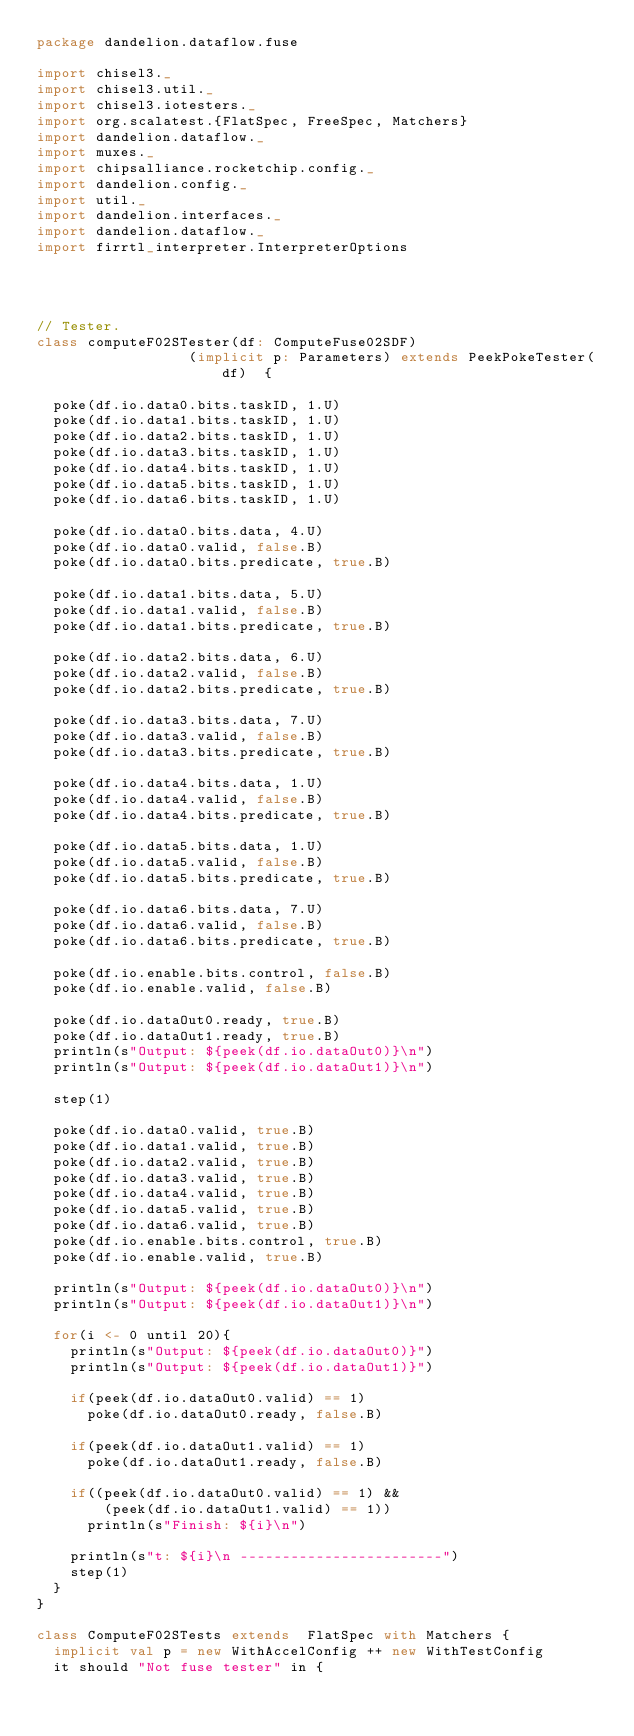Convert code to text. <code><loc_0><loc_0><loc_500><loc_500><_Scala_>package dandelion.dataflow.fuse

import chisel3._
import chisel3.util._
import chisel3.iotesters._
import org.scalatest.{FlatSpec, FreeSpec, Matchers}
import dandelion.dataflow._
import muxes._
import chipsalliance.rocketchip.config._
import dandelion.config._
import util._
import dandelion.interfaces._
import dandelion.dataflow._
import firrtl_interpreter.InterpreterOptions




// Tester.
class computeF02STester(df: ComputeFuse02SDF)
                  (implicit p: Parameters) extends PeekPokeTester(df)  {

  poke(df.io.data0.bits.taskID, 1.U)
  poke(df.io.data1.bits.taskID, 1.U)
  poke(df.io.data2.bits.taskID, 1.U)
  poke(df.io.data3.bits.taskID, 1.U)
  poke(df.io.data4.bits.taskID, 1.U)
  poke(df.io.data5.bits.taskID, 1.U)
  poke(df.io.data6.bits.taskID, 1.U)

  poke(df.io.data0.bits.data, 4.U)
  poke(df.io.data0.valid, false.B)
  poke(df.io.data0.bits.predicate, true.B)

  poke(df.io.data1.bits.data, 5.U)
  poke(df.io.data1.valid, false.B)
  poke(df.io.data1.bits.predicate, true.B)

  poke(df.io.data2.bits.data, 6.U)
  poke(df.io.data2.valid, false.B)
  poke(df.io.data2.bits.predicate, true.B)

  poke(df.io.data3.bits.data, 7.U)
  poke(df.io.data3.valid, false.B)
  poke(df.io.data3.bits.predicate, true.B)

  poke(df.io.data4.bits.data, 1.U)
  poke(df.io.data4.valid, false.B)
  poke(df.io.data4.bits.predicate, true.B)

  poke(df.io.data5.bits.data, 1.U)
  poke(df.io.data5.valid, false.B)
  poke(df.io.data5.bits.predicate, true.B)

  poke(df.io.data6.bits.data, 7.U)
  poke(df.io.data6.valid, false.B)
  poke(df.io.data6.bits.predicate, true.B)

  poke(df.io.enable.bits.control, false.B)
  poke(df.io.enable.valid, false.B)

  poke(df.io.dataOut0.ready, true.B)
  poke(df.io.dataOut1.ready, true.B)
  println(s"Output: ${peek(df.io.dataOut0)}\n")
  println(s"Output: ${peek(df.io.dataOut1)}\n")

  step(1)

  poke(df.io.data0.valid, true.B)
  poke(df.io.data1.valid, true.B)
  poke(df.io.data2.valid, true.B)
  poke(df.io.data3.valid, true.B)
  poke(df.io.data4.valid, true.B)
  poke(df.io.data5.valid, true.B)
  poke(df.io.data6.valid, true.B)
  poke(df.io.enable.bits.control, true.B)
  poke(df.io.enable.valid, true.B)

  println(s"Output: ${peek(df.io.dataOut0)}\n")
  println(s"Output: ${peek(df.io.dataOut1)}\n")

  for(i <- 0 until 20){
    println(s"Output: ${peek(df.io.dataOut0)}")
    println(s"Output: ${peek(df.io.dataOut1)}")

    if(peek(df.io.dataOut0.valid) == 1)
      poke(df.io.dataOut0.ready, false.B)

    if(peek(df.io.dataOut1.valid) == 1)
      poke(df.io.dataOut1.ready, false.B)

    if((peek(df.io.dataOut0.valid) == 1) && 
        (peek(df.io.dataOut1.valid) == 1))
      println(s"Finish: ${i}\n")

    println(s"t: ${i}\n ------------------------")
    step(1)
  }
}

class ComputeF02STests extends  FlatSpec with Matchers {
  implicit val p = new WithAccelConfig ++ new WithTestConfig
  it should "Not fuse tester" in {</code> 